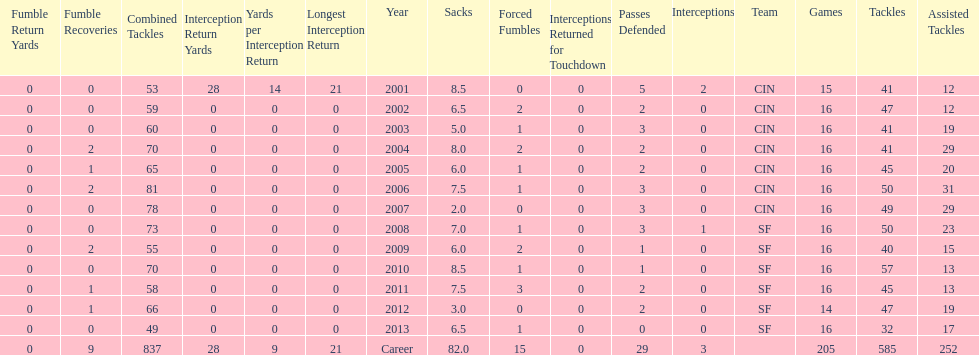What is the average number of tackles this player has had over his career? 45. 